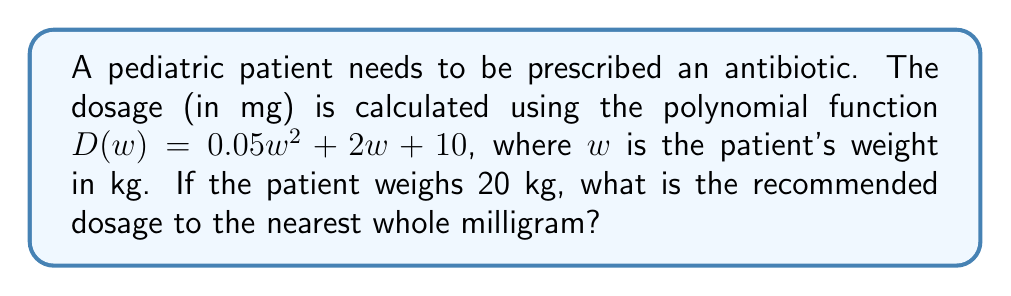Teach me how to tackle this problem. To solve this problem, we need to follow these steps:

1. Identify the given information:
   - The dosage function is $D(w) = 0.05w^2 + 2w + 10$
   - The patient's weight is 20 kg

2. Substitute the patient's weight into the function:
   $D(20) = 0.05(20)^2 + 2(20) + 10$

3. Calculate each term:
   $D(20) = 0.05(400) + 40 + 10$
   $D(20) = 20 + 40 + 10$

4. Sum up the terms:
   $D(20) = 70$

5. Round to the nearest whole milligram:
   The result is already a whole number, so no rounding is necessary.

Therefore, the recommended dosage for a 20 kg patient is 70 mg.
Answer: 70 mg 